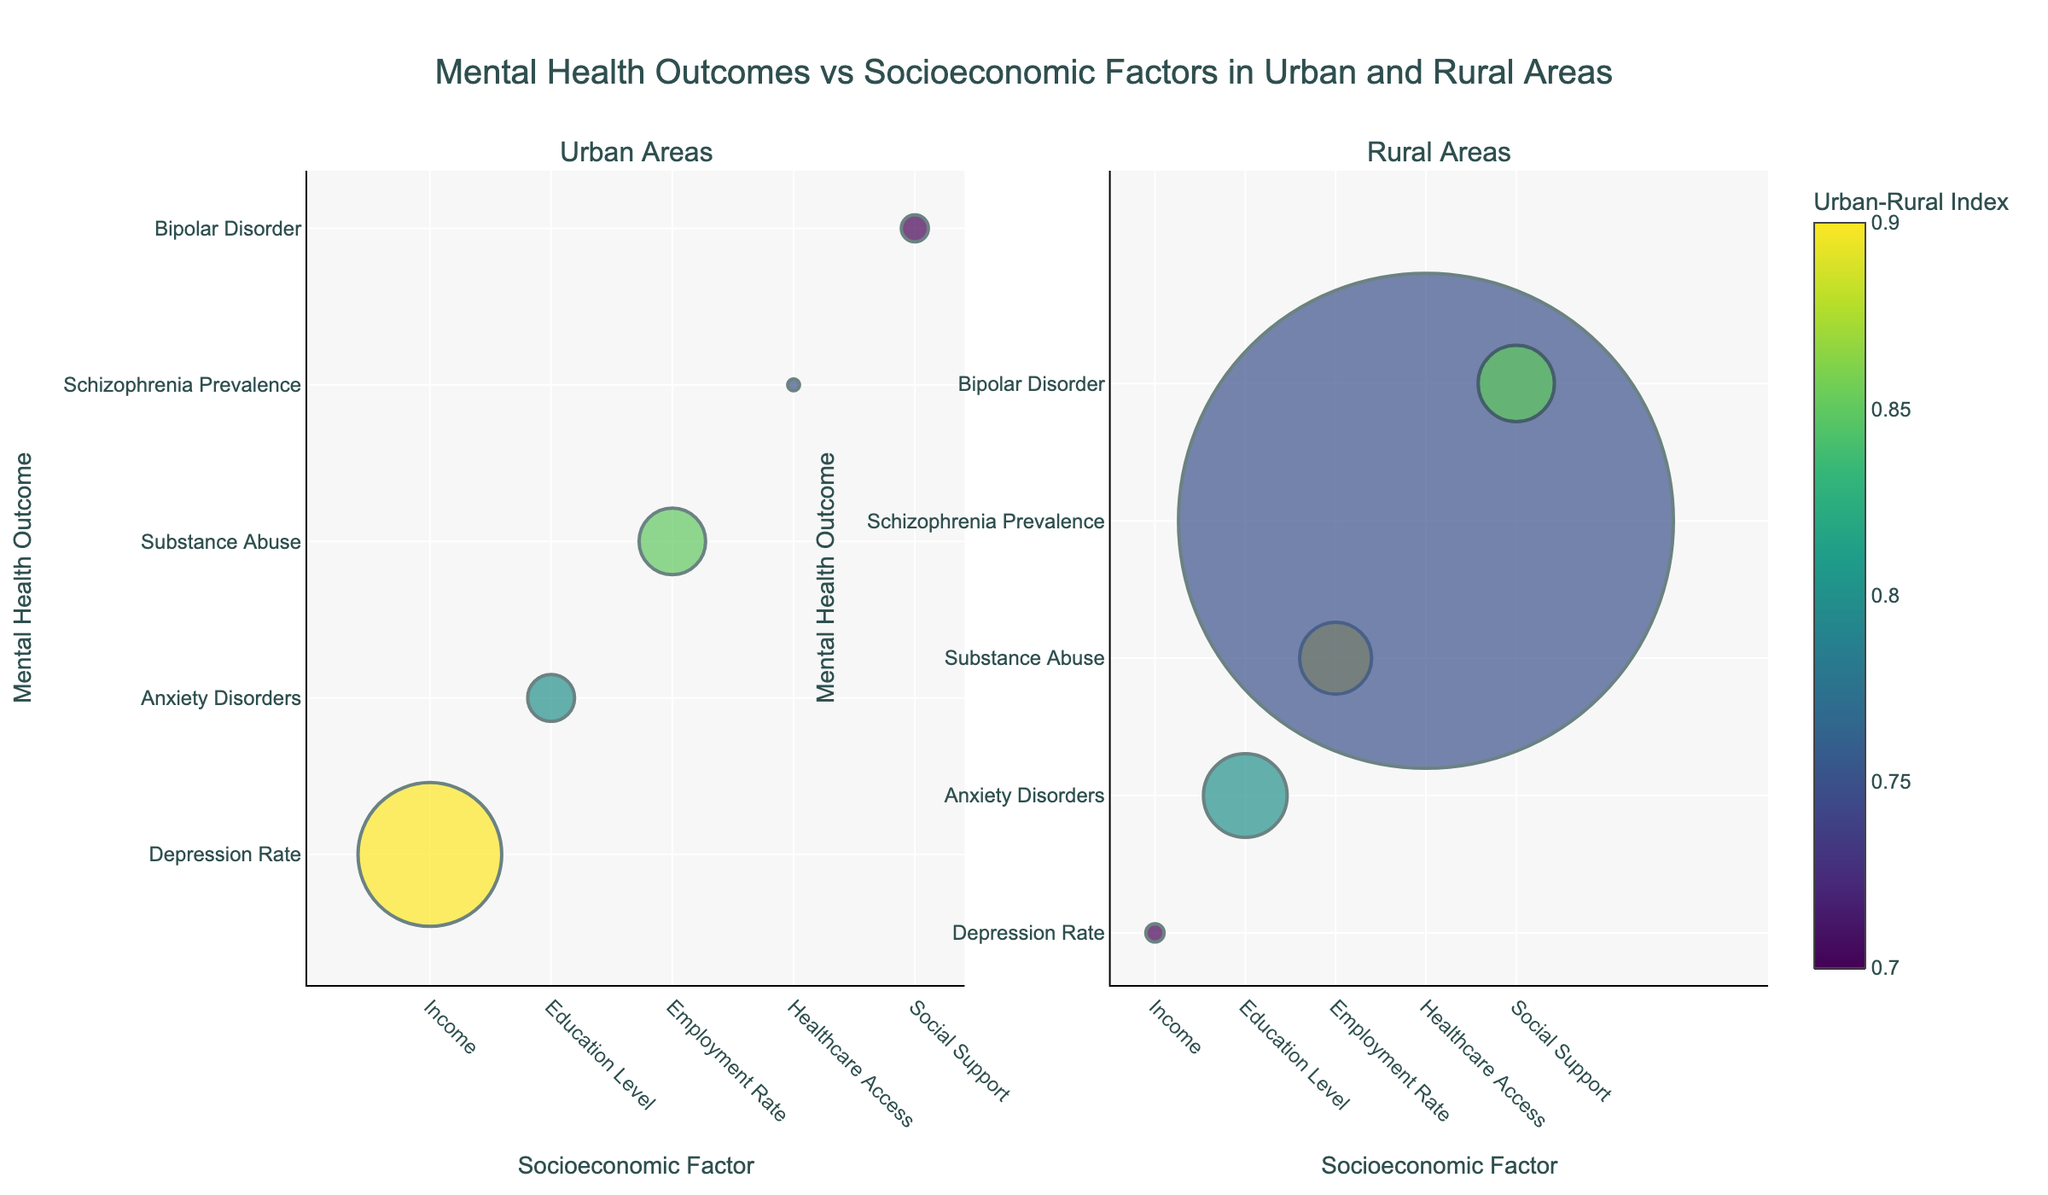What's the title of the figure? The title is located at the top center of the figure and reads: "Mental Health Outcomes vs Socioeconomic Factors in Urban and Rural Areas".
Answer: Mental Health Outcomes vs Socioeconomic Factors in Urban and Rural Areas How is population size represented in the plot? The population size is represented by the size of the bubbles; larger populations are depicted by larger bubbles.
Answer: By the size of the bubbles What does the color of the bubbles represent? The color of the bubbles represents the Urban-Rural Index, with colors ranging according to this index on a Viridis colorscale.
Answer: Urban-Rural Index Which urban area shows data for "Healthcare Access" as a socioeconomic factor? Referring to the urban subplot on the left, "Healthcare Access" as a socioeconomic factor is indicated for Boston.
Answer: Boston Which region has the highest population in the rural subplot? In the rural subplot on the right, the bubble representing Rural Texas is the largest, indicating it has the highest population.
Answer: Rural Texas Compare the depression rate between New York City and Rural Montana. Which has a higher rate? By examining the vertical position of the bubbles labeled "New York City" and "Rural Montana" in the respective subplots, New York City's bubble is higher, showing a higher depression rate compared to Rural Montana.
Answer: New York City What is the socioeconomic factor associated with the highest ranked mental health outcome in the urban areas? In the urban subplot, the bubble highest on the y-axis represents depression rate associated with the "Income" socioeconomic factor in New York City.
Answer: Income Which urban area has the lowest Urban-Rural Index and what is its socioeconomic factor? By observing the color gradient corresponding to the Urban-Rural Index, the bubble for Boston has the lowest index among urban areas, and its socioeconomic factor is "Healthcare Access".
Answer: Boston, Healthcare Access What differences are there in substance abuse rates between urban and rural areas? By comparing the position of bubbles linked to the "Employment Rate" socioeconomic factor in both subplots, the urban subplot shows a bubble for Los Angeles higher than the correspondent bubble in the rural subplot (Rural Oregon), indicating a higher substance abuse rate in the urban area.
Answer: Higher in urban areas (Los Angeles) How many urban areas show data for "Anxiety Disorders"? Observing the urban subplot, there’s one bubble corresponding to "Anxiety Disorders," which is for Chicago.
Answer: One (Chicago) 